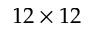Convert formula to latex. <formula><loc_0><loc_0><loc_500><loc_500>1 2 \times 1 2</formula> 